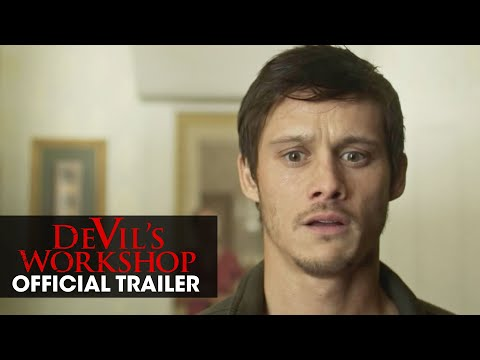Analyze the image in a comprehensive and detailed manner. The image features a man, seemingly in a moment of surprise or confusion, standing against a plain white wall. This man, identified as an actor in the description, is dressed in a gray t-shirt that contrasts with the stark background. His facial expression, characterized by wide eyes and a slightly open mouth, suggests a state of shock or realization. Positioned to the right of the man, the background includes a framed painting, adding a subtle touch of decor to the otherwise minimalistic setting. In the bottom left corner, prominent red letters spell out "Devil's Workshop" and "OFFICIAL TRAILER," indicating that this image is a still from the movie trailer. 